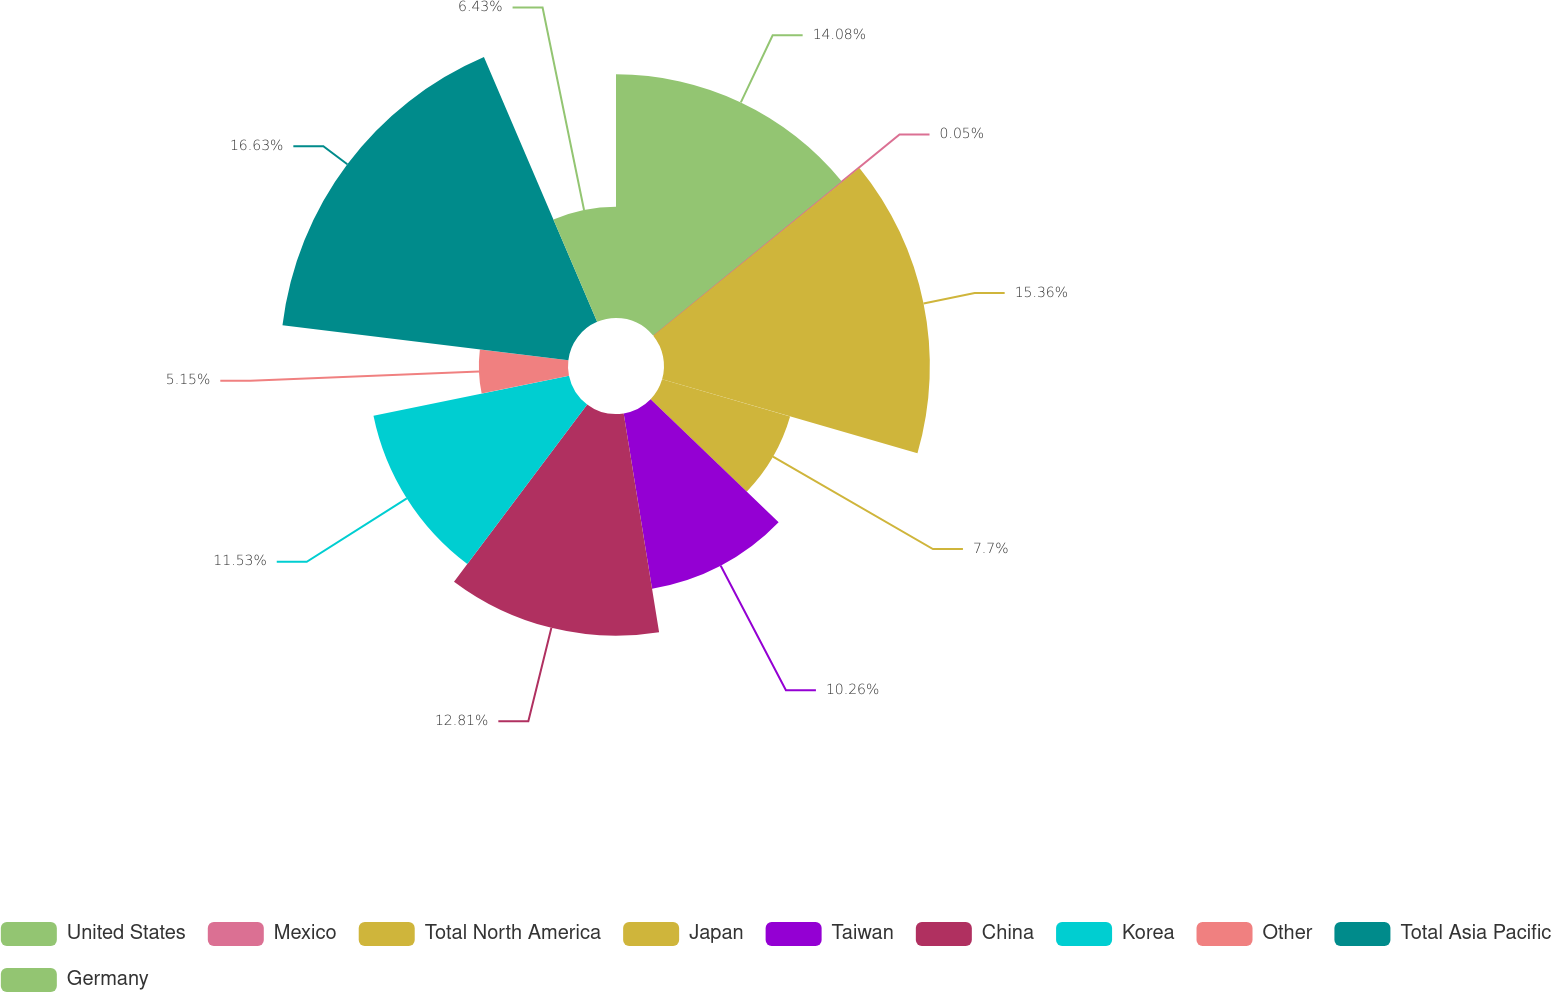<chart> <loc_0><loc_0><loc_500><loc_500><pie_chart><fcel>United States<fcel>Mexico<fcel>Total North America<fcel>Japan<fcel>Taiwan<fcel>China<fcel>Korea<fcel>Other<fcel>Total Asia Pacific<fcel>Germany<nl><fcel>14.08%<fcel>0.05%<fcel>15.36%<fcel>7.7%<fcel>10.26%<fcel>12.81%<fcel>11.53%<fcel>5.15%<fcel>16.64%<fcel>6.43%<nl></chart> 